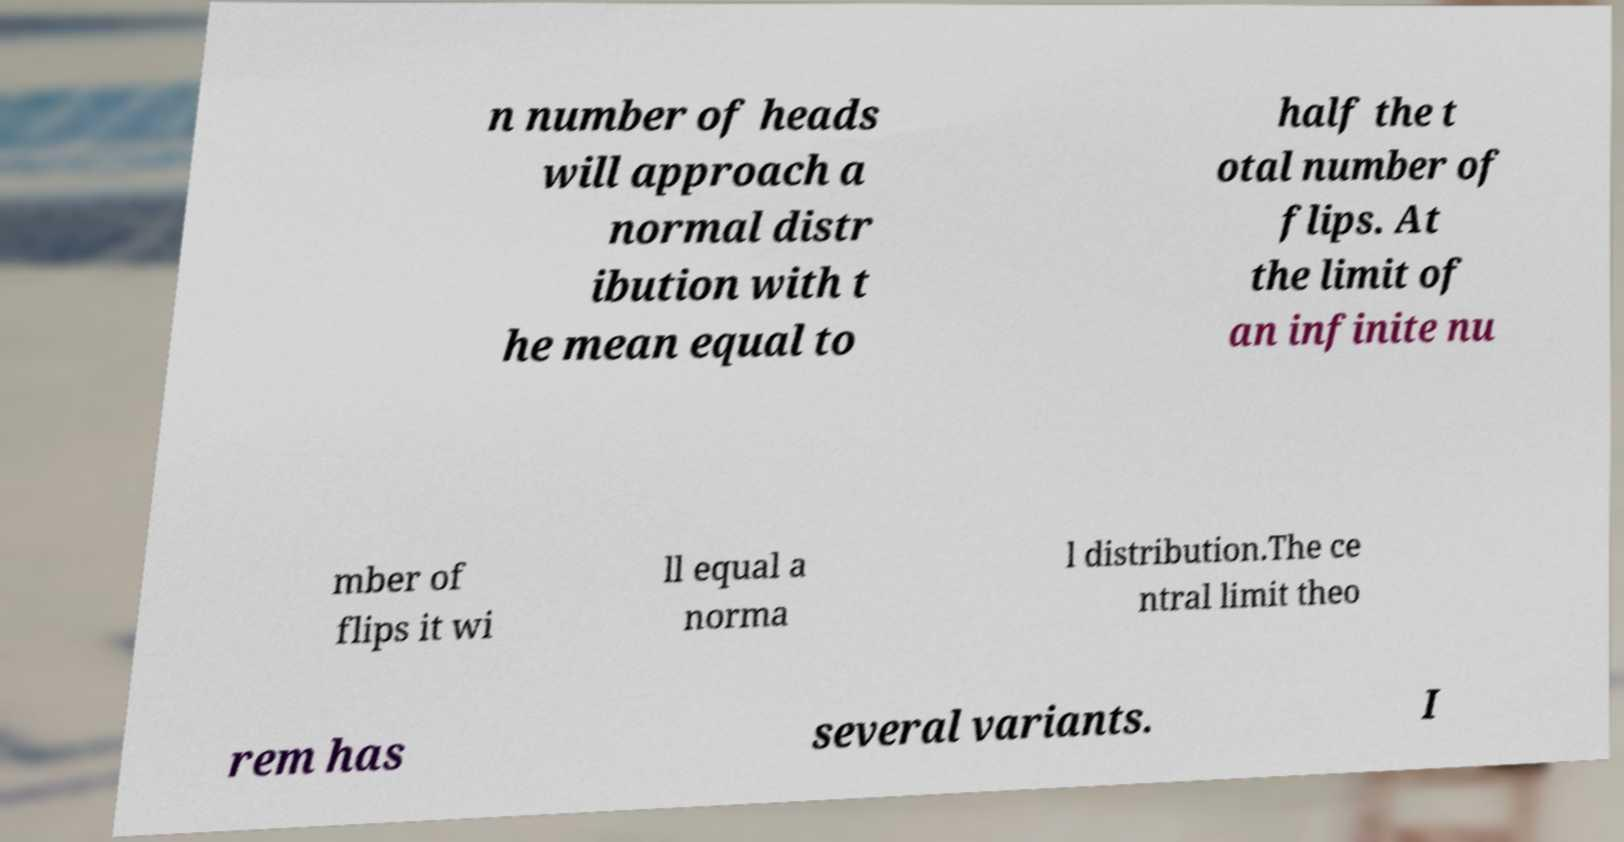Could you assist in decoding the text presented in this image and type it out clearly? n number of heads will approach a normal distr ibution with t he mean equal to half the t otal number of flips. At the limit of an infinite nu mber of flips it wi ll equal a norma l distribution.The ce ntral limit theo rem has several variants. I 